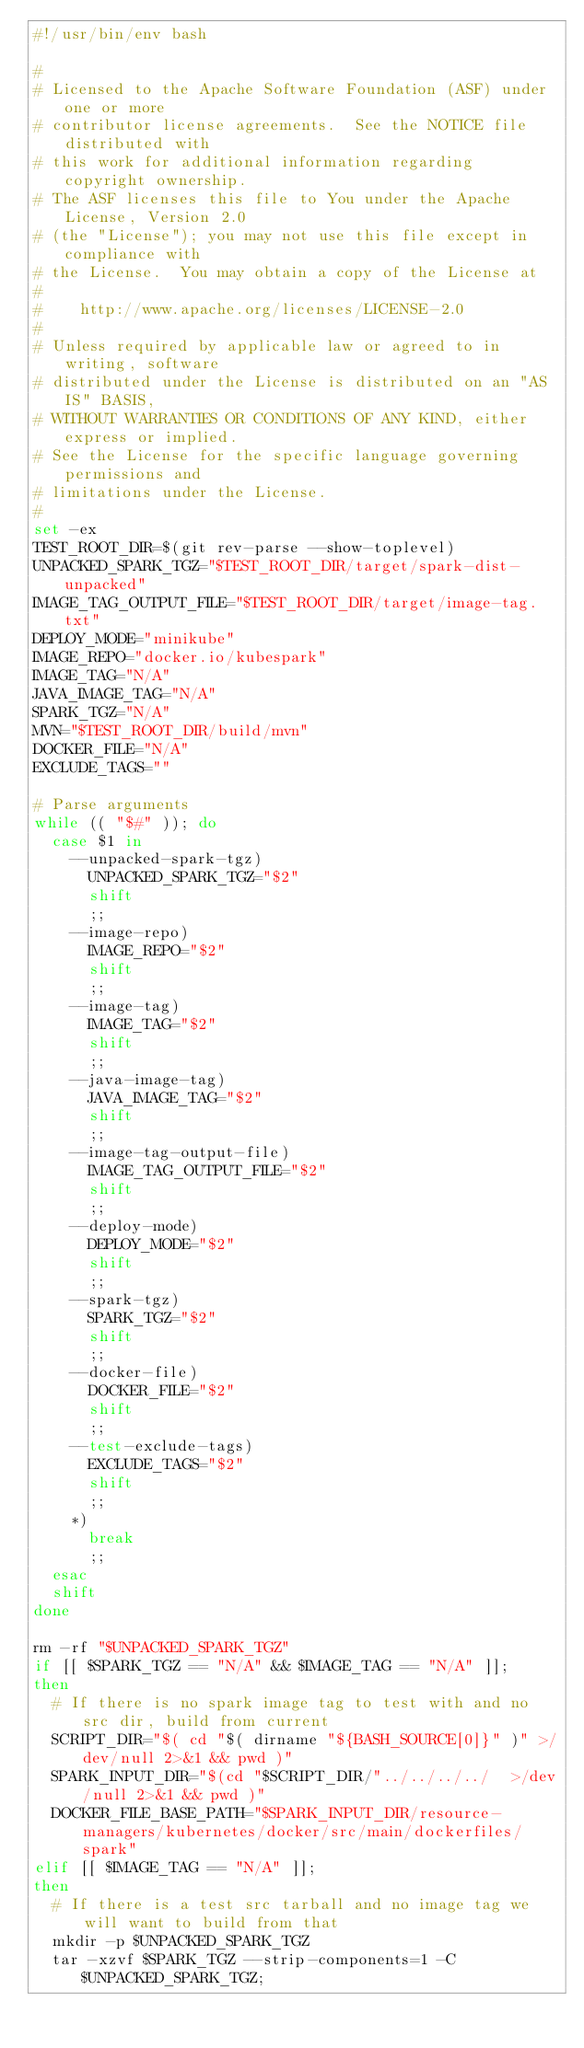<code> <loc_0><loc_0><loc_500><loc_500><_Bash_>#!/usr/bin/env bash

#
# Licensed to the Apache Software Foundation (ASF) under one or more
# contributor license agreements.  See the NOTICE file distributed with
# this work for additional information regarding copyright ownership.
# The ASF licenses this file to You under the Apache License, Version 2.0
# (the "License"); you may not use this file except in compliance with
# the License.  You may obtain a copy of the License at
#
#    http://www.apache.org/licenses/LICENSE-2.0
#
# Unless required by applicable law or agreed to in writing, software
# distributed under the License is distributed on an "AS IS" BASIS,
# WITHOUT WARRANTIES OR CONDITIONS OF ANY KIND, either express or implied.
# See the License for the specific language governing permissions and
# limitations under the License.
#
set -ex
TEST_ROOT_DIR=$(git rev-parse --show-toplevel)
UNPACKED_SPARK_TGZ="$TEST_ROOT_DIR/target/spark-dist-unpacked"
IMAGE_TAG_OUTPUT_FILE="$TEST_ROOT_DIR/target/image-tag.txt"
DEPLOY_MODE="minikube"
IMAGE_REPO="docker.io/kubespark"
IMAGE_TAG="N/A"
JAVA_IMAGE_TAG="N/A"
SPARK_TGZ="N/A"
MVN="$TEST_ROOT_DIR/build/mvn"
DOCKER_FILE="N/A"
EXCLUDE_TAGS=""

# Parse arguments
while (( "$#" )); do
  case $1 in
    --unpacked-spark-tgz)
      UNPACKED_SPARK_TGZ="$2"
      shift
      ;;
    --image-repo)
      IMAGE_REPO="$2"
      shift
      ;;
    --image-tag)
      IMAGE_TAG="$2"
      shift
      ;;
    --java-image-tag)
      JAVA_IMAGE_TAG="$2"
      shift
      ;;
    --image-tag-output-file)
      IMAGE_TAG_OUTPUT_FILE="$2"
      shift
      ;;
    --deploy-mode)
      DEPLOY_MODE="$2"
      shift
      ;;
    --spark-tgz)
      SPARK_TGZ="$2"
      shift
      ;;
    --docker-file)
      DOCKER_FILE="$2"
      shift
      ;;
    --test-exclude-tags)
      EXCLUDE_TAGS="$2"
      shift
      ;;
    *)
      break
      ;;
  esac
  shift
done

rm -rf "$UNPACKED_SPARK_TGZ"
if [[ $SPARK_TGZ == "N/A" && $IMAGE_TAG == "N/A" ]];
then
  # If there is no spark image tag to test with and no src dir, build from current
  SCRIPT_DIR="$( cd "$( dirname "${BASH_SOURCE[0]}" )" >/dev/null 2>&1 && pwd )"
  SPARK_INPUT_DIR="$(cd "$SCRIPT_DIR/"../../../../  >/dev/null 2>&1 && pwd )"
  DOCKER_FILE_BASE_PATH="$SPARK_INPUT_DIR/resource-managers/kubernetes/docker/src/main/dockerfiles/spark"
elif [[ $IMAGE_TAG == "N/A" ]];
then
  # If there is a test src tarball and no image tag we will want to build from that
  mkdir -p $UNPACKED_SPARK_TGZ
  tar -xzvf $SPARK_TGZ --strip-components=1 -C $UNPACKED_SPARK_TGZ;</code> 